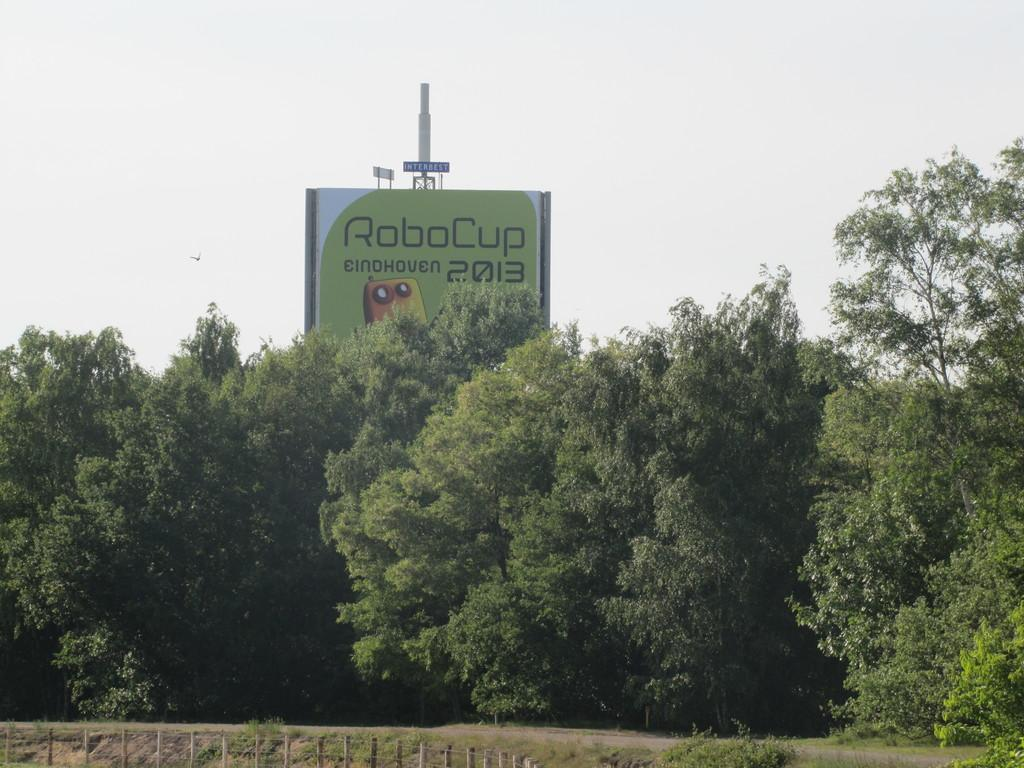What type of vegetation is present in the image? There are trees in the image. What is the color of the trees? The trees are green. What structure can be seen in the image, attached to a pole? There is a board attached to a pole in the image. What is visible in the background of the image? The sky is visible in the image. What is the color of the sky in the image? The color of the sky is white. What type of body is visible in the image? There is no body present in the image; it features trees, a board attached to a pole, and a white sky. Can you tell me what type of guitar is being played in the image? There is no guitar present in the image. 